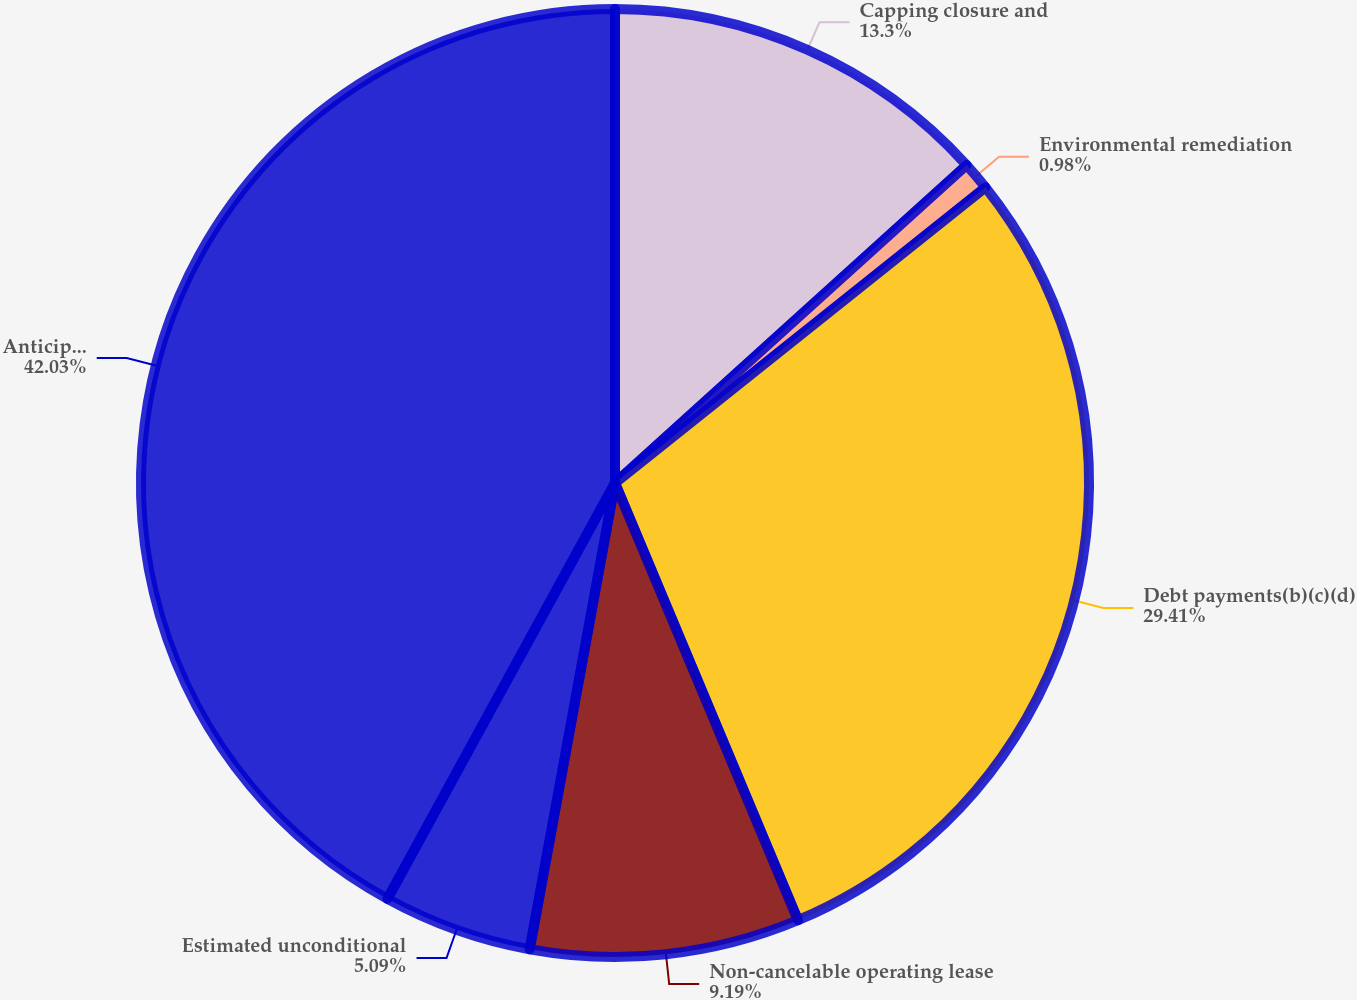Convert chart. <chart><loc_0><loc_0><loc_500><loc_500><pie_chart><fcel>Capping closure and<fcel>Environmental remediation<fcel>Debt payments(b)(c)(d)<fcel>Non-cancelable operating lease<fcel>Estimated unconditional<fcel>Anticipated liquidity impact<nl><fcel>13.3%<fcel>0.98%<fcel>29.41%<fcel>9.19%<fcel>5.09%<fcel>42.03%<nl></chart> 